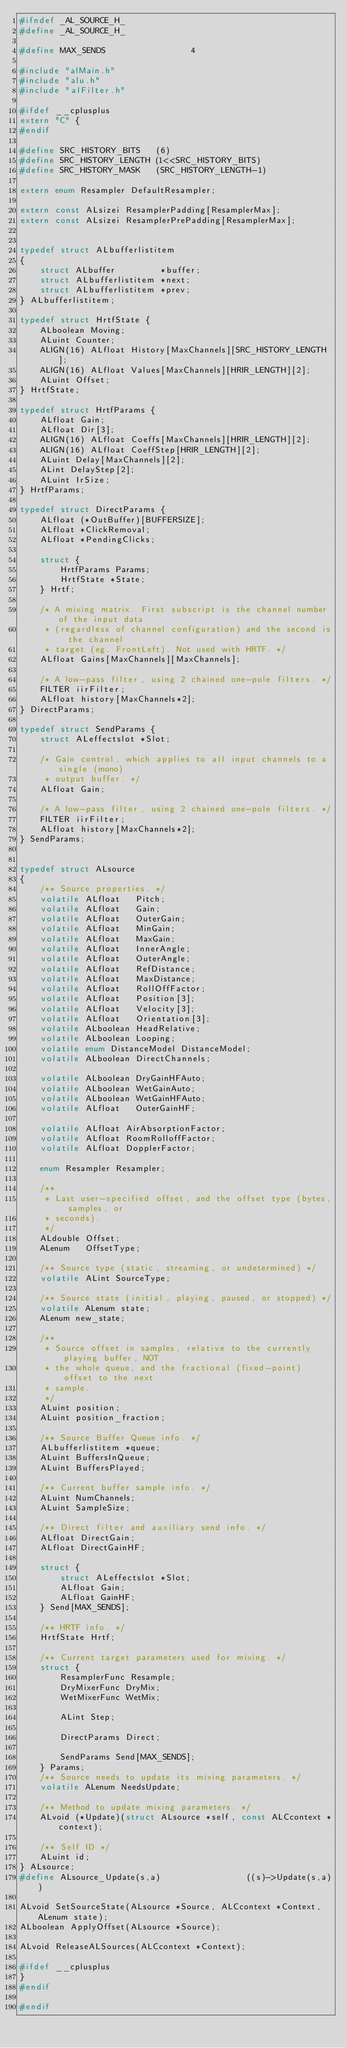<code> <loc_0><loc_0><loc_500><loc_500><_C_>#ifndef _AL_SOURCE_H_
#define _AL_SOURCE_H_

#define MAX_SENDS                 4

#include "alMain.h"
#include "alu.h"
#include "alFilter.h"

#ifdef __cplusplus
extern "C" {
#endif

#define SRC_HISTORY_BITS   (6)
#define SRC_HISTORY_LENGTH (1<<SRC_HISTORY_BITS)
#define SRC_HISTORY_MASK   (SRC_HISTORY_LENGTH-1)

extern enum Resampler DefaultResampler;

extern const ALsizei ResamplerPadding[ResamplerMax];
extern const ALsizei ResamplerPrePadding[ResamplerMax];


typedef struct ALbufferlistitem
{
    struct ALbuffer         *buffer;
    struct ALbufferlistitem *next;
    struct ALbufferlistitem *prev;
} ALbufferlistitem;

typedef struct HrtfState {
    ALboolean Moving;
    ALuint Counter;
    ALIGN(16) ALfloat History[MaxChannels][SRC_HISTORY_LENGTH];
    ALIGN(16) ALfloat Values[MaxChannels][HRIR_LENGTH][2];
    ALuint Offset;
} HrtfState;

typedef struct HrtfParams {
    ALfloat Gain;
    ALfloat Dir[3];
    ALIGN(16) ALfloat Coeffs[MaxChannels][HRIR_LENGTH][2];
    ALIGN(16) ALfloat CoeffStep[HRIR_LENGTH][2];
    ALuint Delay[MaxChannels][2];
    ALint DelayStep[2];
    ALuint IrSize;
} HrtfParams;

typedef struct DirectParams {
    ALfloat (*OutBuffer)[BUFFERSIZE];
    ALfloat *ClickRemoval;
    ALfloat *PendingClicks;

    struct {
        HrtfParams Params;
        HrtfState *State;
    } Hrtf;

    /* A mixing matrix. First subscript is the channel number of the input data
     * (regardless of channel configuration) and the second is the channel
     * target (eg. FrontLeft). Not used with HRTF. */
    ALfloat Gains[MaxChannels][MaxChannels];

    /* A low-pass filter, using 2 chained one-pole filters. */
    FILTER iirFilter;
    ALfloat history[MaxChannels*2];
} DirectParams;

typedef struct SendParams {
    struct ALeffectslot *Slot;

    /* Gain control, which applies to all input channels to a single (mono)
     * output buffer. */
    ALfloat Gain;

    /* A low-pass filter, using 2 chained one-pole filters. */
    FILTER iirFilter;
    ALfloat history[MaxChannels*2];
} SendParams;


typedef struct ALsource
{
    /** Source properties. */
    volatile ALfloat   Pitch;
    volatile ALfloat   Gain;
    volatile ALfloat   OuterGain;
    volatile ALfloat   MinGain;
    volatile ALfloat   MaxGain;
    volatile ALfloat   InnerAngle;
    volatile ALfloat   OuterAngle;
    volatile ALfloat   RefDistance;
    volatile ALfloat   MaxDistance;
    volatile ALfloat   RollOffFactor;
    volatile ALfloat   Position[3];
    volatile ALfloat   Velocity[3];
    volatile ALfloat   Orientation[3];
    volatile ALboolean HeadRelative;
    volatile ALboolean Looping;
    volatile enum DistanceModel DistanceModel;
    volatile ALboolean DirectChannels;

    volatile ALboolean DryGainHFAuto;
    volatile ALboolean WetGainAuto;
    volatile ALboolean WetGainHFAuto;
    volatile ALfloat   OuterGainHF;

    volatile ALfloat AirAbsorptionFactor;
    volatile ALfloat RoomRolloffFactor;
    volatile ALfloat DopplerFactor;

    enum Resampler Resampler;

    /**
     * Last user-specified offset, and the offset type (bytes, samples, or
     * seconds).
     */
    ALdouble Offset;
    ALenum   OffsetType;

    /** Source type (static, streaming, or undetermined) */
    volatile ALint SourceType;

    /** Source state (initial, playing, paused, or stopped) */
    volatile ALenum state;
    ALenum new_state;

    /**
     * Source offset in samples, relative to the currently playing buffer, NOT
     * the whole queue, and the fractional (fixed-point) offset to the next
     * sample.
     */
    ALuint position;
    ALuint position_fraction;

    /** Source Buffer Queue info. */
    ALbufferlistitem *queue;
    ALuint BuffersInQueue;
    ALuint BuffersPlayed;

    /** Current buffer sample info. */
    ALuint NumChannels;
    ALuint SampleSize;

    /** Direct filter and auxiliary send info. */
    ALfloat DirectGain;
    ALfloat DirectGainHF;

    struct {
        struct ALeffectslot *Slot;
        ALfloat Gain;
        ALfloat GainHF;
    } Send[MAX_SENDS];

    /** HRTF info. */
    HrtfState Hrtf;

    /** Current target parameters used for mixing. */
    struct {
        ResamplerFunc Resample;
        DryMixerFunc DryMix;
        WetMixerFunc WetMix;

        ALint Step;

        DirectParams Direct;

        SendParams Send[MAX_SENDS];
    } Params;
    /** Source needs to update its mixing parameters. */
    volatile ALenum NeedsUpdate;

    /** Method to update mixing parameters. */
    ALvoid (*Update)(struct ALsource *self, const ALCcontext *context);

    /** Self ID */
    ALuint id;
} ALsource;
#define ALsource_Update(s,a)                 ((s)->Update(s,a))

ALvoid SetSourceState(ALsource *Source, ALCcontext *Context, ALenum state);
ALboolean ApplyOffset(ALsource *Source);

ALvoid ReleaseALSources(ALCcontext *Context);

#ifdef __cplusplus
}
#endif

#endif
</code> 